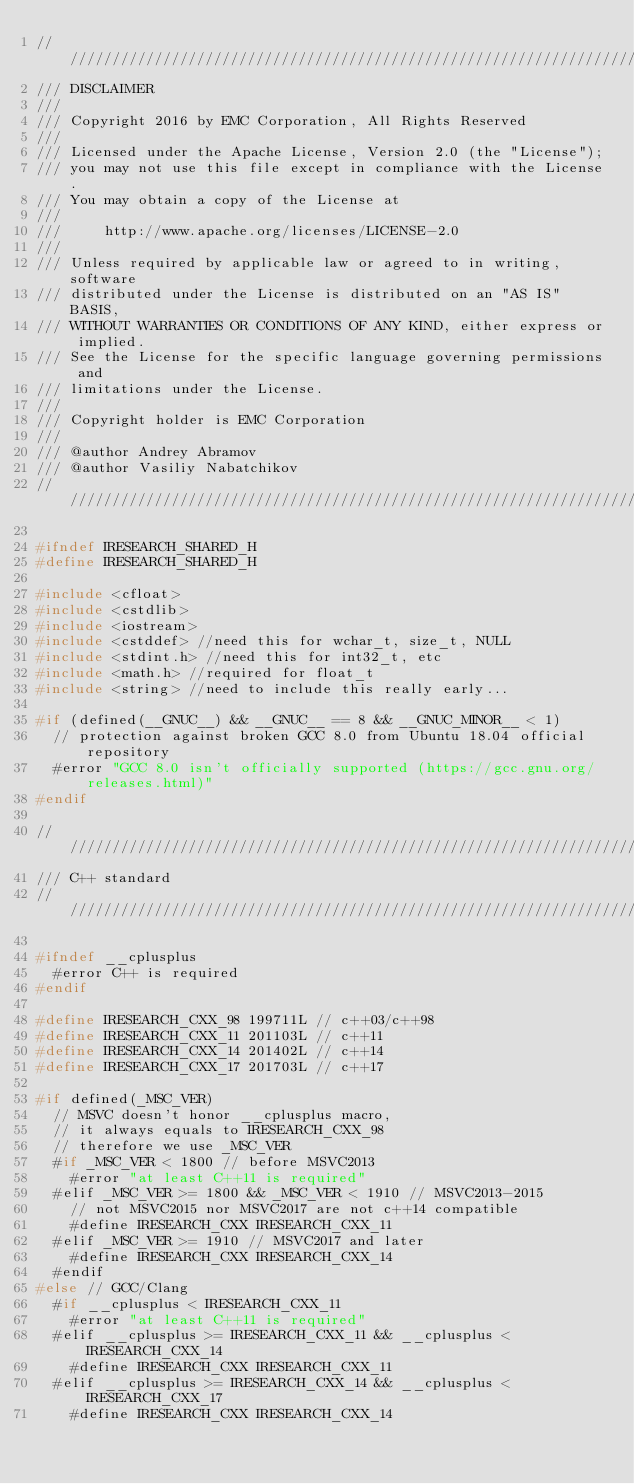<code> <loc_0><loc_0><loc_500><loc_500><_C++_>////////////////////////////////////////////////////////////////////////////////
/// DISCLAIMER
///
/// Copyright 2016 by EMC Corporation, All Rights Reserved
///
/// Licensed under the Apache License, Version 2.0 (the "License");
/// you may not use this file except in compliance with the License.
/// You may obtain a copy of the License at
///
///     http://www.apache.org/licenses/LICENSE-2.0
///
/// Unless required by applicable law or agreed to in writing, software
/// distributed under the License is distributed on an "AS IS" BASIS,
/// WITHOUT WARRANTIES OR CONDITIONS OF ANY KIND, either express or implied.
/// See the License for the specific language governing permissions and
/// limitations under the License.
///
/// Copyright holder is EMC Corporation
///
/// @author Andrey Abramov
/// @author Vasiliy Nabatchikov
////////////////////////////////////////////////////////////////////////////////

#ifndef IRESEARCH_SHARED_H
#define IRESEARCH_SHARED_H

#include <cfloat>
#include <cstdlib>
#include <iostream>
#include <cstddef> //need this for wchar_t, size_t, NULL
#include <stdint.h> //need this for int32_t, etc
#include <math.h> //required for float_t
#include <string> //need to include this really early...

#if (defined(__GNUC__) && __GNUC__ == 8 && __GNUC_MINOR__ < 1)
  // protection against broken GCC 8.0 from Ubuntu 18.04 official repository
  #error "GCC 8.0 isn't officially supported (https://gcc.gnu.org/releases.html)"
#endif

////////////////////////////////////////////////////////////////////////////////
/// C++ standard
////////////////////////////////////////////////////////////////////////////////

#ifndef __cplusplus
  #error C++ is required
#endif

#define IRESEARCH_CXX_98 199711L // c++03/c++98
#define IRESEARCH_CXX_11 201103L // c++11
#define IRESEARCH_CXX_14 201402L // c++14
#define IRESEARCH_CXX_17 201703L // c++17

#if defined(_MSC_VER)
  // MSVC doesn't honor __cplusplus macro,
  // it always equals to IRESEARCH_CXX_98
  // therefore we use _MSC_VER
  #if _MSC_VER < 1800 // before MSVC2013
    #error "at least C++11 is required"
  #elif _MSC_VER >= 1800 && _MSC_VER < 1910 // MSVC2013-2015
    // not MSVC2015 nor MSVC2017 are not c++14 compatible
    #define IRESEARCH_CXX IRESEARCH_CXX_11
  #elif _MSC_VER >= 1910 // MSVC2017 and later
    #define IRESEARCH_CXX IRESEARCH_CXX_14
  #endif
#else // GCC/Clang
  #if __cplusplus < IRESEARCH_CXX_11
    #error "at least C++11 is required"
  #elif __cplusplus >= IRESEARCH_CXX_11 && __cplusplus < IRESEARCH_CXX_14
    #define IRESEARCH_CXX IRESEARCH_CXX_11
  #elif __cplusplus >= IRESEARCH_CXX_14 && __cplusplus < IRESEARCH_CXX_17
    #define IRESEARCH_CXX IRESEARCH_CXX_14</code> 